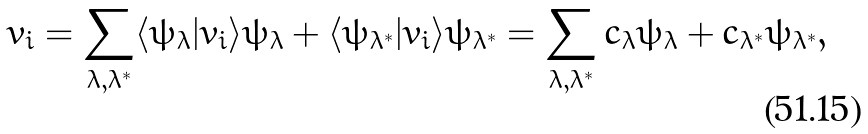<formula> <loc_0><loc_0><loc_500><loc_500>v _ { i } = \sum _ { \lambda , \lambda ^ { * } } \langle \psi _ { \lambda } | v _ { i } \rangle \psi _ { \lambda } + \langle \psi _ { \lambda ^ { * } } | v _ { i } \rangle \psi _ { \lambda ^ { * } } = \sum _ { \lambda , \lambda ^ { * } } c _ { \lambda } \psi _ { \lambda } + c _ { \lambda ^ { * } } \psi _ { \lambda ^ { * } } ,</formula> 